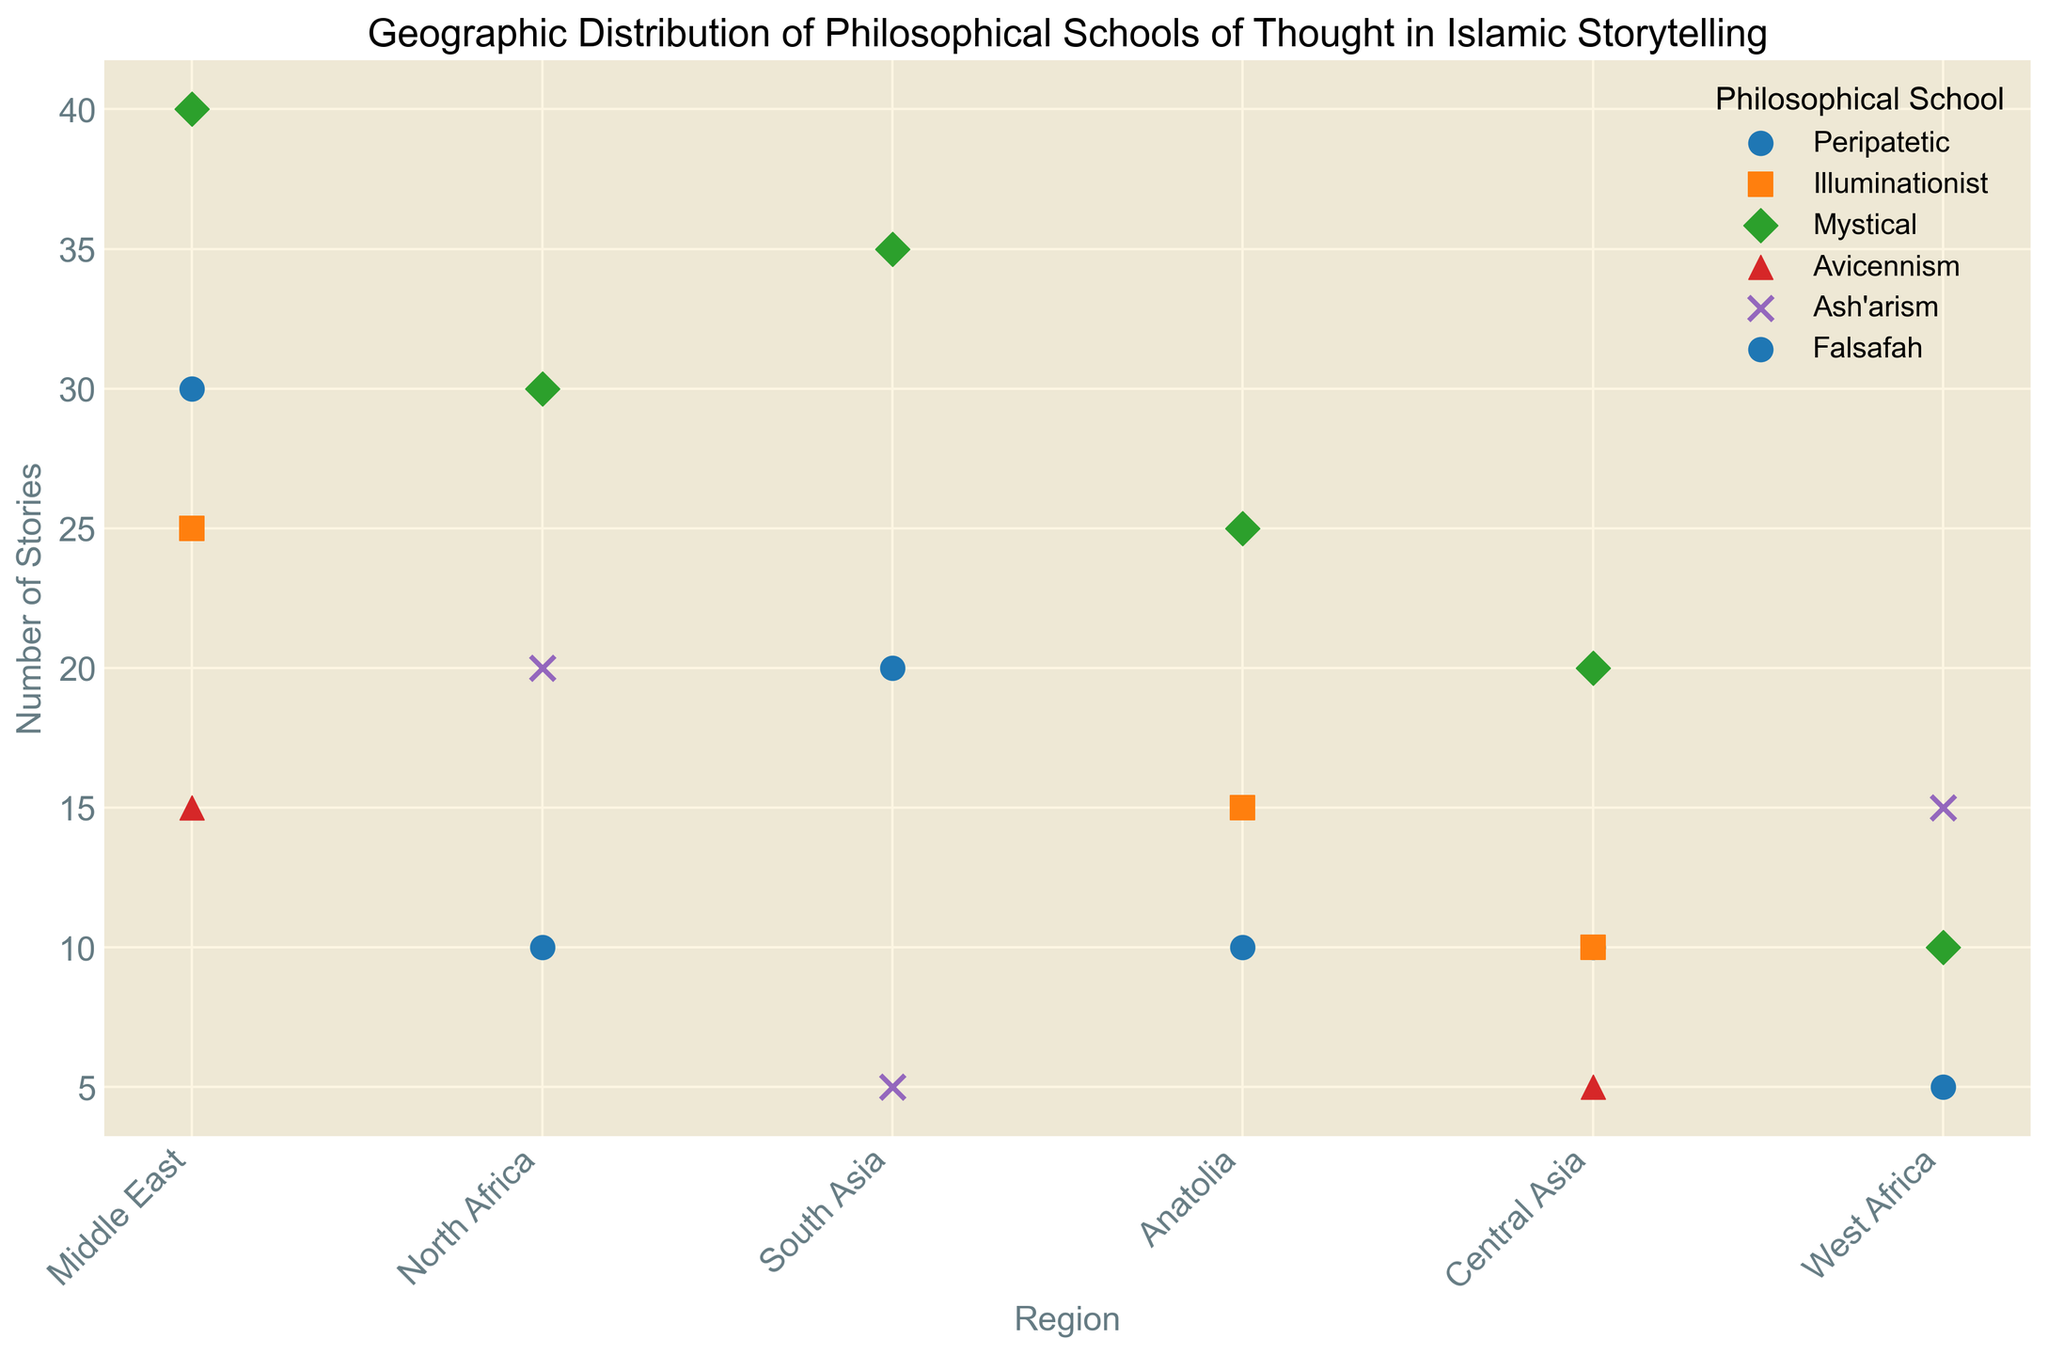What region has the highest number of stories involving the Mystical school? The data points show that the Mystical school has 40 stories in the Middle East, which is the highest count among all regions for this school.
Answer: Middle East How many more stories of the Peripatetic school are found in the Middle East compared to Central Asia? The Peripatetic school has 30 stories in the Middle East and 10 in Central Asia. The difference is 30 - 10 = 20.
Answer: 20 Which region exhibits the most diversity in terms of the number of stories across different philosophical schools? The Middle East has shown stories from Peripatetic, Illuminationist, Mystical, and Avicennism schools, summing to four different schools. This suggests a high degree of diversity.
Answer: Middle East Which philosophical school has the highest number of stories overall across regions? Summing up the counts for each school across different regions, the Mystical school has the highest total with 160 stories.
Answer: Mystical If you sum the number of Ash'arism stories across all regions, what is the total? Adding the counts from North Africa (20), South Asia (5), and West Africa (15), the total is 20 + 5 + 15 = 40.
Answer: 40 How does the number of Avicennism stories in the Middle East compare to that in Central Asia? The Middle East has 15 stories of Avicennism while Central Asia has 5. Thus, the Middle East has 10 more stories than Central Asia.
Answer: Middle East What region has the fewest total stories compared to other regions? Summing the stories for each region: 
Middle East (110), North Africa (60), South Asia (60), Anatolia (50), Central Asia (45), West Africa (30).
West Africa has the fewest total stories with 30.
Answer: West Africa How does the presence of the Illuminationist school compare between the Middle East and Anatolia? The Middle East has 25 stories related to the Illuminationist school, whereas Anatolia has 15. Thus, the Middle East has 10 more stories of this school than Anatolia.
Answer: Middle East Which philosophical school is predominant in South Asia in terms of the number of stories? Observing the data points for South Asia, the Mystical school has the most stories with a count of 35.
Answer: Mystical What is the combined total of stories for Peripatetic and Falsafah schools in Central Asia? The Peripatetic school has 10 stories and the Falsafah school has no representation in Central Asia. Hence, the combined total is 10 + 0 = 10.
Answer: 10 